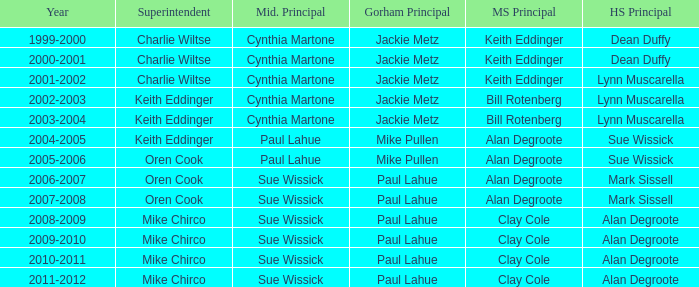How many high school principals were there in 2000-2001? Dean Duffy. 